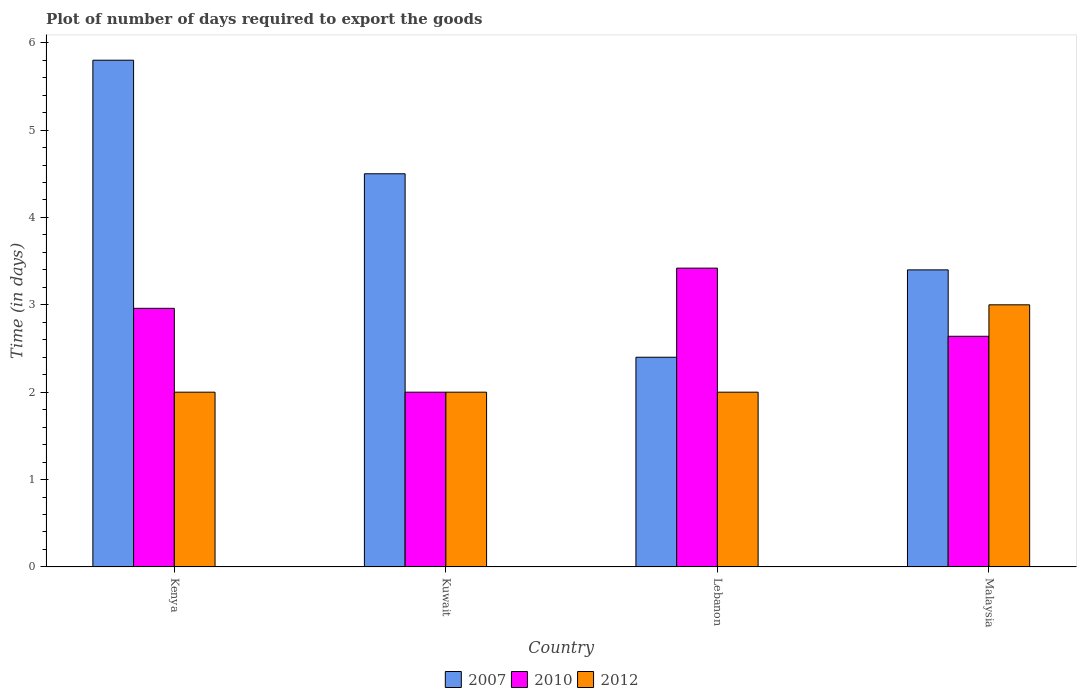Are the number of bars per tick equal to the number of legend labels?
Ensure brevity in your answer.  Yes. How many bars are there on the 2nd tick from the left?
Ensure brevity in your answer.  3. How many bars are there on the 3rd tick from the right?
Your answer should be very brief. 3. What is the label of the 2nd group of bars from the left?
Provide a succinct answer. Kuwait. Across all countries, what is the maximum time required to export goods in 2007?
Your answer should be very brief. 5.8. In which country was the time required to export goods in 2007 maximum?
Provide a short and direct response. Kenya. In which country was the time required to export goods in 2010 minimum?
Make the answer very short. Kuwait. What is the total time required to export goods in 2012 in the graph?
Keep it short and to the point. 9. What is the difference between the time required to export goods in 2007 in Lebanon and that in Malaysia?
Offer a very short reply. -1. What is the difference between the time required to export goods in 2010 in Kenya and the time required to export goods in 2007 in Malaysia?
Your answer should be compact. -0.44. What is the average time required to export goods in 2007 per country?
Your answer should be very brief. 4.03. What is the ratio of the time required to export goods in 2012 in Kenya to that in Lebanon?
Offer a very short reply. 1. What is the difference between the highest and the second highest time required to export goods in 2010?
Offer a terse response. -0.46. What is the difference between the highest and the lowest time required to export goods in 2010?
Provide a succinct answer. 1.42. In how many countries, is the time required to export goods in 2010 greater than the average time required to export goods in 2010 taken over all countries?
Provide a short and direct response. 2. Is the sum of the time required to export goods in 2007 in Kenya and Kuwait greater than the maximum time required to export goods in 2012 across all countries?
Your answer should be compact. Yes. What does the 1st bar from the right in Kenya represents?
Make the answer very short. 2012. How many countries are there in the graph?
Provide a short and direct response. 4. What is the difference between two consecutive major ticks on the Y-axis?
Your answer should be compact. 1. Are the values on the major ticks of Y-axis written in scientific E-notation?
Provide a short and direct response. No. Does the graph contain grids?
Keep it short and to the point. No. How many legend labels are there?
Your answer should be compact. 3. What is the title of the graph?
Provide a succinct answer. Plot of number of days required to export the goods. What is the label or title of the X-axis?
Your answer should be compact. Country. What is the label or title of the Y-axis?
Your answer should be very brief. Time (in days). What is the Time (in days) of 2007 in Kenya?
Offer a terse response. 5.8. What is the Time (in days) of 2010 in Kenya?
Make the answer very short. 2.96. What is the Time (in days) of 2010 in Kuwait?
Provide a succinct answer. 2. What is the Time (in days) of 2012 in Kuwait?
Provide a short and direct response. 2. What is the Time (in days) in 2007 in Lebanon?
Your response must be concise. 2.4. What is the Time (in days) in 2010 in Lebanon?
Provide a short and direct response. 3.42. What is the Time (in days) in 2010 in Malaysia?
Provide a short and direct response. 2.64. What is the Time (in days) of 2012 in Malaysia?
Your answer should be very brief. 3. Across all countries, what is the maximum Time (in days) of 2010?
Provide a short and direct response. 3.42. Across all countries, what is the maximum Time (in days) of 2012?
Provide a short and direct response. 3. Across all countries, what is the minimum Time (in days) in 2012?
Offer a terse response. 2. What is the total Time (in days) of 2010 in the graph?
Your answer should be very brief. 11.02. What is the total Time (in days) in 2012 in the graph?
Your answer should be very brief. 9. What is the difference between the Time (in days) of 2010 in Kenya and that in Kuwait?
Give a very brief answer. 0.96. What is the difference between the Time (in days) in 2012 in Kenya and that in Kuwait?
Your answer should be compact. 0. What is the difference between the Time (in days) in 2010 in Kenya and that in Lebanon?
Make the answer very short. -0.46. What is the difference between the Time (in days) of 2007 in Kenya and that in Malaysia?
Your answer should be compact. 2.4. What is the difference between the Time (in days) of 2010 in Kenya and that in Malaysia?
Your response must be concise. 0.32. What is the difference between the Time (in days) of 2007 in Kuwait and that in Lebanon?
Provide a succinct answer. 2.1. What is the difference between the Time (in days) of 2010 in Kuwait and that in Lebanon?
Provide a succinct answer. -1.42. What is the difference between the Time (in days) of 2012 in Kuwait and that in Lebanon?
Provide a succinct answer. 0. What is the difference between the Time (in days) of 2007 in Kuwait and that in Malaysia?
Your answer should be compact. 1.1. What is the difference between the Time (in days) in 2010 in Kuwait and that in Malaysia?
Your response must be concise. -0.64. What is the difference between the Time (in days) of 2007 in Lebanon and that in Malaysia?
Keep it short and to the point. -1. What is the difference between the Time (in days) in 2010 in Lebanon and that in Malaysia?
Your answer should be very brief. 0.78. What is the difference between the Time (in days) in 2007 in Kenya and the Time (in days) in 2010 in Kuwait?
Provide a short and direct response. 3.8. What is the difference between the Time (in days) in 2007 in Kenya and the Time (in days) in 2012 in Kuwait?
Your response must be concise. 3.8. What is the difference between the Time (in days) in 2007 in Kenya and the Time (in days) in 2010 in Lebanon?
Your answer should be compact. 2.38. What is the difference between the Time (in days) of 2007 in Kenya and the Time (in days) of 2012 in Lebanon?
Provide a succinct answer. 3.8. What is the difference between the Time (in days) of 2007 in Kenya and the Time (in days) of 2010 in Malaysia?
Your answer should be compact. 3.16. What is the difference between the Time (in days) of 2010 in Kenya and the Time (in days) of 2012 in Malaysia?
Your answer should be compact. -0.04. What is the difference between the Time (in days) in 2007 in Kuwait and the Time (in days) in 2010 in Lebanon?
Provide a succinct answer. 1.08. What is the difference between the Time (in days) in 2010 in Kuwait and the Time (in days) in 2012 in Lebanon?
Your response must be concise. 0. What is the difference between the Time (in days) of 2007 in Kuwait and the Time (in days) of 2010 in Malaysia?
Give a very brief answer. 1.86. What is the difference between the Time (in days) of 2007 in Lebanon and the Time (in days) of 2010 in Malaysia?
Make the answer very short. -0.24. What is the difference between the Time (in days) in 2010 in Lebanon and the Time (in days) in 2012 in Malaysia?
Offer a terse response. 0.42. What is the average Time (in days) of 2007 per country?
Your answer should be compact. 4.03. What is the average Time (in days) in 2010 per country?
Offer a terse response. 2.75. What is the average Time (in days) of 2012 per country?
Your answer should be compact. 2.25. What is the difference between the Time (in days) of 2007 and Time (in days) of 2010 in Kenya?
Your response must be concise. 2.84. What is the difference between the Time (in days) of 2007 and Time (in days) of 2012 in Kenya?
Your answer should be very brief. 3.8. What is the difference between the Time (in days) of 2007 and Time (in days) of 2010 in Kuwait?
Your response must be concise. 2.5. What is the difference between the Time (in days) in 2007 and Time (in days) in 2010 in Lebanon?
Ensure brevity in your answer.  -1.02. What is the difference between the Time (in days) in 2010 and Time (in days) in 2012 in Lebanon?
Provide a short and direct response. 1.42. What is the difference between the Time (in days) of 2007 and Time (in days) of 2010 in Malaysia?
Give a very brief answer. 0.76. What is the difference between the Time (in days) in 2007 and Time (in days) in 2012 in Malaysia?
Provide a short and direct response. 0.4. What is the difference between the Time (in days) of 2010 and Time (in days) of 2012 in Malaysia?
Offer a terse response. -0.36. What is the ratio of the Time (in days) in 2007 in Kenya to that in Kuwait?
Make the answer very short. 1.29. What is the ratio of the Time (in days) of 2010 in Kenya to that in Kuwait?
Offer a very short reply. 1.48. What is the ratio of the Time (in days) of 2007 in Kenya to that in Lebanon?
Your answer should be very brief. 2.42. What is the ratio of the Time (in days) in 2010 in Kenya to that in Lebanon?
Your answer should be compact. 0.87. What is the ratio of the Time (in days) of 2007 in Kenya to that in Malaysia?
Provide a short and direct response. 1.71. What is the ratio of the Time (in days) of 2010 in Kenya to that in Malaysia?
Keep it short and to the point. 1.12. What is the ratio of the Time (in days) of 2007 in Kuwait to that in Lebanon?
Your answer should be compact. 1.88. What is the ratio of the Time (in days) in 2010 in Kuwait to that in Lebanon?
Your answer should be compact. 0.58. What is the ratio of the Time (in days) of 2007 in Kuwait to that in Malaysia?
Your answer should be compact. 1.32. What is the ratio of the Time (in days) of 2010 in Kuwait to that in Malaysia?
Your answer should be compact. 0.76. What is the ratio of the Time (in days) in 2012 in Kuwait to that in Malaysia?
Your answer should be very brief. 0.67. What is the ratio of the Time (in days) of 2007 in Lebanon to that in Malaysia?
Your answer should be compact. 0.71. What is the ratio of the Time (in days) in 2010 in Lebanon to that in Malaysia?
Offer a terse response. 1.3. What is the ratio of the Time (in days) of 2012 in Lebanon to that in Malaysia?
Provide a short and direct response. 0.67. What is the difference between the highest and the second highest Time (in days) in 2007?
Make the answer very short. 1.3. What is the difference between the highest and the second highest Time (in days) of 2010?
Your response must be concise. 0.46. What is the difference between the highest and the second highest Time (in days) of 2012?
Make the answer very short. 1. What is the difference between the highest and the lowest Time (in days) of 2007?
Your response must be concise. 3.4. What is the difference between the highest and the lowest Time (in days) of 2010?
Provide a short and direct response. 1.42. 